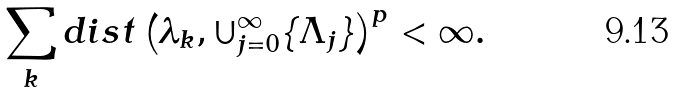Convert formula to latex. <formula><loc_0><loc_0><loc_500><loc_500>\sum _ { k } d i s t \left ( \lambda _ { k } , \cup _ { j = 0 } ^ { \infty } \{ \Lambda _ { j } \} \right ) ^ { p } < \infty .</formula> 